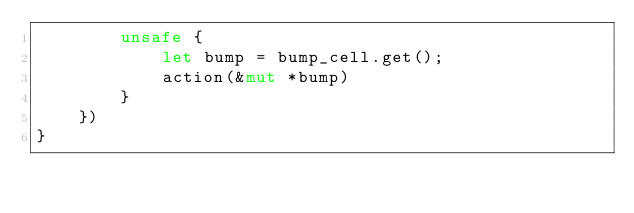Convert code to text. <code><loc_0><loc_0><loc_500><loc_500><_Rust_>        unsafe {
            let bump = bump_cell.get();
            action(&mut *bump)
        }
    })
}</code> 